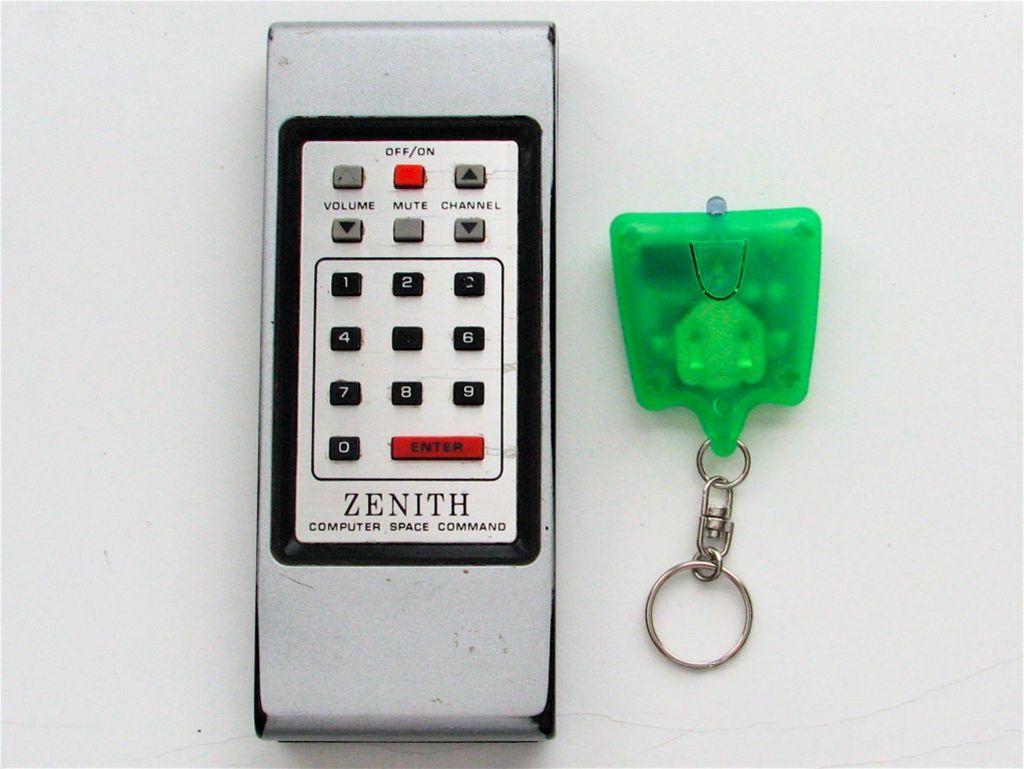What kind of space command is it?
Your answer should be compact. Computer. 